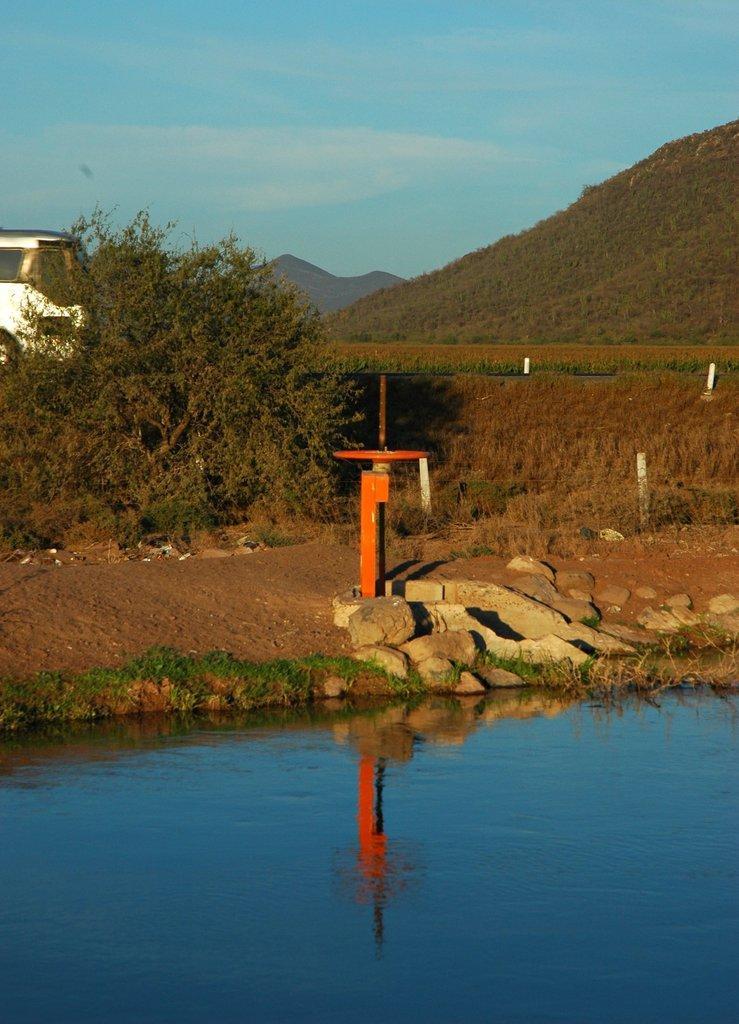How would you summarize this image in a sentence or two? At the bottom there is water, on the left side there is a tree. At the top it is the sky. 